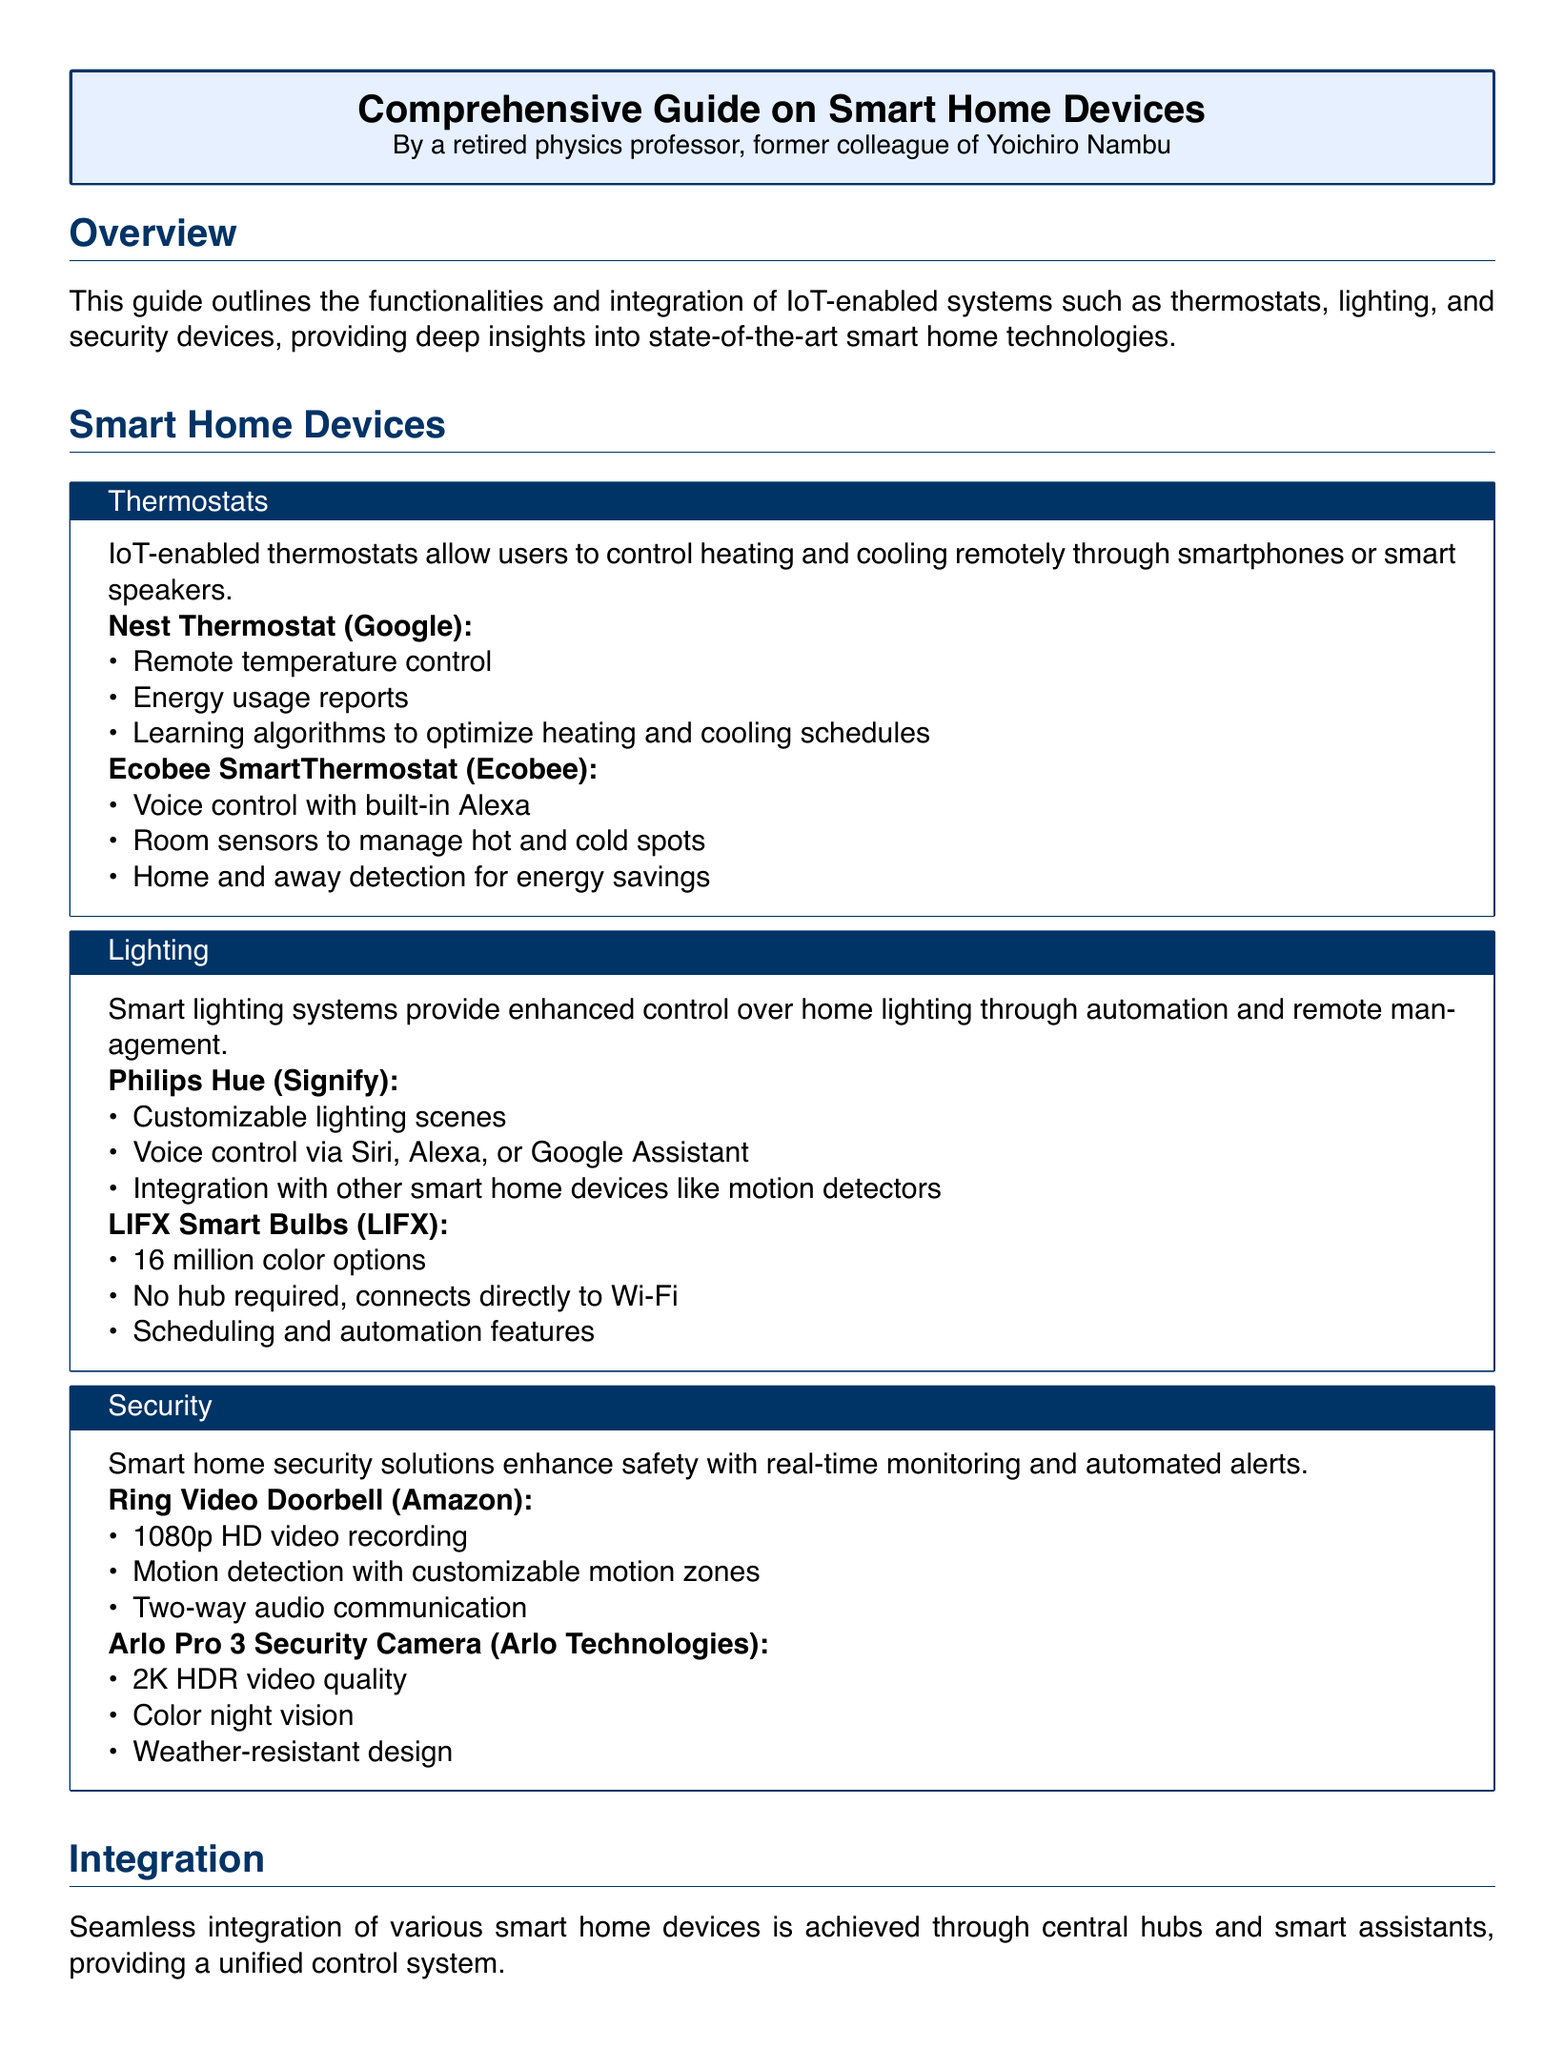What is the core purpose of this guide? The guide outlines the functionalities and integration of IoT-enabled systems such as thermostats, lighting, and security devices.
Answer: functionalities and integration of IoT-enabled systems What are the two models of IoT-enabled thermostats mentioned? The document lists specific models of thermostats under the Thermostats section.
Answer: Nest Thermostat, Ecobee SmartThermostat Which smart lighting system allows for 16 million color options? This is found in the Lighting section where the features of different smart lighting systems are described.
Answer: LIFX Smart Bulbs What does the Ring Video Doorbell feature? Features of the Ring Video Doorbell are outlined in the Security section.
Answer: 1080p HD video recording How does the Amazon Echo facilitate smart device control? The document explains the role of the Amazon Echo in device integration and control, indicating its functions.
Answer: Voice control for multiple smart devices What is the voice control assistant integrated with the Ecobee SmartThermostat? This information is found in the detailed features of the Ecobee model within the Thermostats section.
Answer: Alexa What is required to connect LIFX Smart Bulbs? The document mentions specific connection requirements for various smart bulbs, including the LIFX model.
Answer: No hub required, connects directly to Wi-Fi Which device provides a touchscreen interface for control? The integration section mentions a specific device that includes a touchscreen for management.
Answer: Google Nest Hub What type of control does the Philips Hue offer? The Philips Hue features are detailed in the Lighting section, indicating its capabilities.
Answer: Customizable lighting scenes 